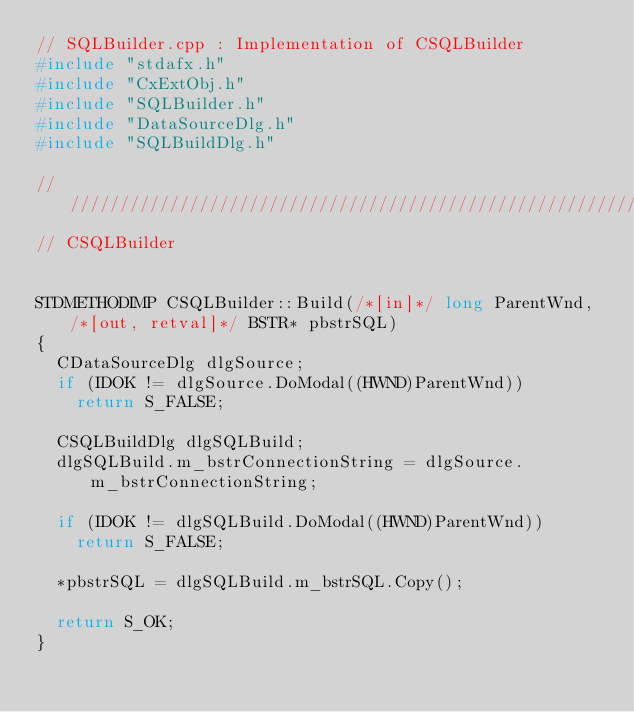Convert code to text. <code><loc_0><loc_0><loc_500><loc_500><_C++_>// SQLBuilder.cpp : Implementation of CSQLBuilder
#include "stdafx.h"
#include "CxExtObj.h"
#include "SQLBuilder.h"
#include "DataSourceDlg.h"
#include "SQLBuildDlg.h"

/////////////////////////////////////////////////////////////////////////////
// CSQLBuilder


STDMETHODIMP CSQLBuilder::Build(/*[in]*/ long ParentWnd, /*[out, retval]*/ BSTR* pbstrSQL)
{
	CDataSourceDlg dlgSource;
	if (IDOK != dlgSource.DoModal((HWND)ParentWnd))
		return S_FALSE;

	CSQLBuildDlg dlgSQLBuild;
	dlgSQLBuild.m_bstrConnectionString = dlgSource.m_bstrConnectionString;

	if (IDOK != dlgSQLBuild.DoModal((HWND)ParentWnd))
		return S_FALSE;

	*pbstrSQL = dlgSQLBuild.m_bstrSQL.Copy();

	return S_OK;
}
</code> 